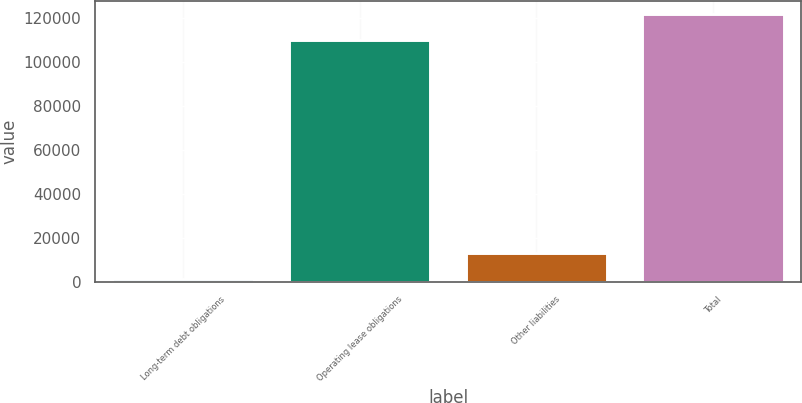Convert chart to OTSL. <chart><loc_0><loc_0><loc_500><loc_500><bar_chart><fcel>Long-term debt obligations<fcel>Operating lease obligations<fcel>Other liabilities<fcel>Total<nl><fcel>1261<fcel>109982<fcel>13293.5<fcel>122014<nl></chart> 